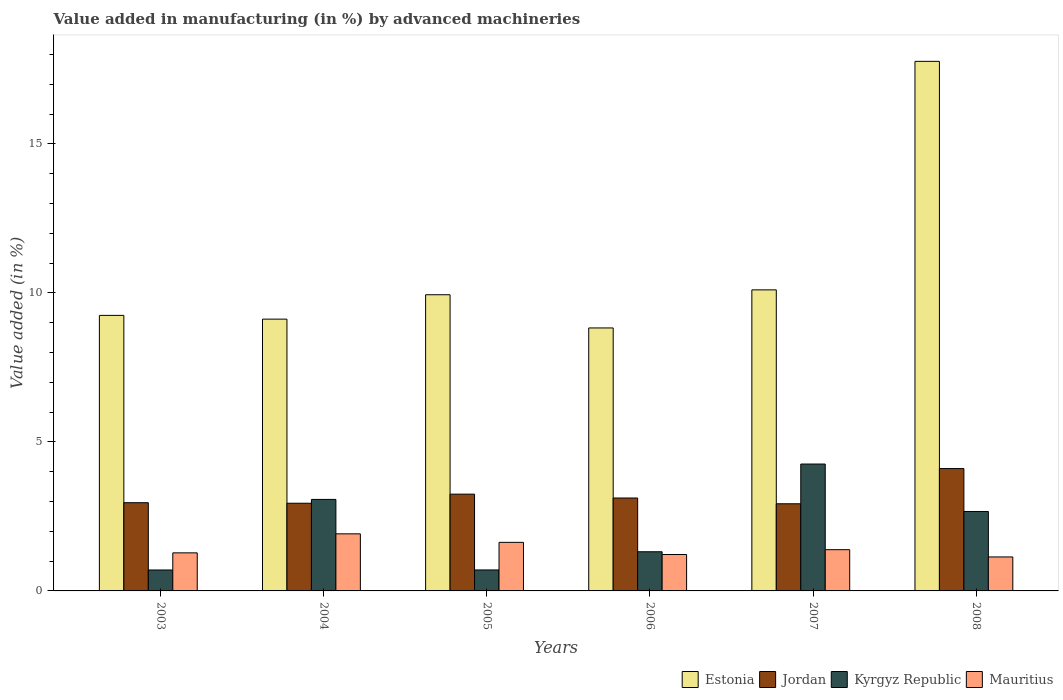How many bars are there on the 3rd tick from the left?
Keep it short and to the point. 4. What is the label of the 5th group of bars from the left?
Offer a terse response. 2007. In how many cases, is the number of bars for a given year not equal to the number of legend labels?
Make the answer very short. 0. What is the percentage of value added in manufacturing by advanced machineries in Mauritius in 2004?
Provide a short and direct response. 1.92. Across all years, what is the maximum percentage of value added in manufacturing by advanced machineries in Kyrgyz Republic?
Provide a short and direct response. 4.26. Across all years, what is the minimum percentage of value added in manufacturing by advanced machineries in Mauritius?
Provide a short and direct response. 1.14. In which year was the percentage of value added in manufacturing by advanced machineries in Kyrgyz Republic maximum?
Make the answer very short. 2007. In which year was the percentage of value added in manufacturing by advanced machineries in Mauritius minimum?
Provide a short and direct response. 2008. What is the total percentage of value added in manufacturing by advanced machineries in Jordan in the graph?
Ensure brevity in your answer.  19.3. What is the difference between the percentage of value added in manufacturing by advanced machineries in Kyrgyz Republic in 2003 and that in 2005?
Your answer should be compact. -0. What is the difference between the percentage of value added in manufacturing by advanced machineries in Mauritius in 2008 and the percentage of value added in manufacturing by advanced machineries in Jordan in 2004?
Provide a short and direct response. -1.8. What is the average percentage of value added in manufacturing by advanced machineries in Mauritius per year?
Offer a terse response. 1.43. In the year 2003, what is the difference between the percentage of value added in manufacturing by advanced machineries in Mauritius and percentage of value added in manufacturing by advanced machineries in Jordan?
Offer a terse response. -1.68. In how many years, is the percentage of value added in manufacturing by advanced machineries in Jordan greater than 7 %?
Offer a very short reply. 0. What is the ratio of the percentage of value added in manufacturing by advanced machineries in Mauritius in 2006 to that in 2008?
Your answer should be very brief. 1.07. Is the difference between the percentage of value added in manufacturing by advanced machineries in Mauritius in 2006 and 2007 greater than the difference between the percentage of value added in manufacturing by advanced machineries in Jordan in 2006 and 2007?
Ensure brevity in your answer.  No. What is the difference between the highest and the second highest percentage of value added in manufacturing by advanced machineries in Mauritius?
Ensure brevity in your answer.  0.29. What is the difference between the highest and the lowest percentage of value added in manufacturing by advanced machineries in Jordan?
Ensure brevity in your answer.  1.18. Is the sum of the percentage of value added in manufacturing by advanced machineries in Kyrgyz Republic in 2006 and 2007 greater than the maximum percentage of value added in manufacturing by advanced machineries in Estonia across all years?
Your answer should be compact. No. What does the 1st bar from the left in 2003 represents?
Ensure brevity in your answer.  Estonia. What does the 4th bar from the right in 2007 represents?
Your answer should be compact. Estonia. Are all the bars in the graph horizontal?
Offer a terse response. No. Does the graph contain any zero values?
Your answer should be compact. No. Does the graph contain grids?
Offer a terse response. No. What is the title of the graph?
Give a very brief answer. Value added in manufacturing (in %) by advanced machineries. What is the label or title of the X-axis?
Provide a succinct answer. Years. What is the label or title of the Y-axis?
Your answer should be very brief. Value added (in %). What is the Value added (in %) of Estonia in 2003?
Ensure brevity in your answer.  9.25. What is the Value added (in %) in Jordan in 2003?
Your answer should be very brief. 2.96. What is the Value added (in %) of Kyrgyz Republic in 2003?
Provide a short and direct response. 0.7. What is the Value added (in %) in Mauritius in 2003?
Offer a very short reply. 1.28. What is the Value added (in %) of Estonia in 2004?
Offer a terse response. 9.12. What is the Value added (in %) in Jordan in 2004?
Ensure brevity in your answer.  2.94. What is the Value added (in %) of Kyrgyz Republic in 2004?
Your response must be concise. 3.07. What is the Value added (in %) in Mauritius in 2004?
Provide a succinct answer. 1.92. What is the Value added (in %) in Estonia in 2005?
Ensure brevity in your answer.  9.94. What is the Value added (in %) of Jordan in 2005?
Your response must be concise. 3.25. What is the Value added (in %) of Kyrgyz Republic in 2005?
Ensure brevity in your answer.  0.7. What is the Value added (in %) of Mauritius in 2005?
Provide a succinct answer. 1.63. What is the Value added (in %) in Estonia in 2006?
Your response must be concise. 8.83. What is the Value added (in %) of Jordan in 2006?
Make the answer very short. 3.12. What is the Value added (in %) in Kyrgyz Republic in 2006?
Keep it short and to the point. 1.31. What is the Value added (in %) in Mauritius in 2006?
Offer a very short reply. 1.22. What is the Value added (in %) in Estonia in 2007?
Your response must be concise. 10.1. What is the Value added (in %) in Jordan in 2007?
Provide a succinct answer. 2.92. What is the Value added (in %) in Kyrgyz Republic in 2007?
Provide a succinct answer. 4.26. What is the Value added (in %) of Mauritius in 2007?
Keep it short and to the point. 1.38. What is the Value added (in %) of Estonia in 2008?
Your answer should be very brief. 17.77. What is the Value added (in %) of Jordan in 2008?
Your answer should be compact. 4.11. What is the Value added (in %) of Kyrgyz Republic in 2008?
Give a very brief answer. 2.67. What is the Value added (in %) of Mauritius in 2008?
Ensure brevity in your answer.  1.14. Across all years, what is the maximum Value added (in %) of Estonia?
Your answer should be compact. 17.77. Across all years, what is the maximum Value added (in %) of Jordan?
Give a very brief answer. 4.11. Across all years, what is the maximum Value added (in %) in Kyrgyz Republic?
Provide a short and direct response. 4.26. Across all years, what is the maximum Value added (in %) in Mauritius?
Your answer should be compact. 1.92. Across all years, what is the minimum Value added (in %) in Estonia?
Provide a succinct answer. 8.83. Across all years, what is the minimum Value added (in %) in Jordan?
Your answer should be very brief. 2.92. Across all years, what is the minimum Value added (in %) of Kyrgyz Republic?
Ensure brevity in your answer.  0.7. Across all years, what is the minimum Value added (in %) of Mauritius?
Provide a succinct answer. 1.14. What is the total Value added (in %) of Estonia in the graph?
Keep it short and to the point. 65.01. What is the total Value added (in %) of Jordan in the graph?
Offer a very short reply. 19.3. What is the total Value added (in %) of Kyrgyz Republic in the graph?
Give a very brief answer. 12.72. What is the total Value added (in %) in Mauritius in the graph?
Make the answer very short. 8.57. What is the difference between the Value added (in %) of Estonia in 2003 and that in 2004?
Keep it short and to the point. 0.13. What is the difference between the Value added (in %) of Jordan in 2003 and that in 2004?
Your response must be concise. 0.02. What is the difference between the Value added (in %) in Kyrgyz Republic in 2003 and that in 2004?
Your answer should be very brief. -2.37. What is the difference between the Value added (in %) in Mauritius in 2003 and that in 2004?
Provide a short and direct response. -0.64. What is the difference between the Value added (in %) in Estonia in 2003 and that in 2005?
Keep it short and to the point. -0.69. What is the difference between the Value added (in %) in Jordan in 2003 and that in 2005?
Offer a terse response. -0.29. What is the difference between the Value added (in %) of Kyrgyz Republic in 2003 and that in 2005?
Provide a succinct answer. -0. What is the difference between the Value added (in %) of Mauritius in 2003 and that in 2005?
Ensure brevity in your answer.  -0.35. What is the difference between the Value added (in %) of Estonia in 2003 and that in 2006?
Your answer should be compact. 0.42. What is the difference between the Value added (in %) in Jordan in 2003 and that in 2006?
Ensure brevity in your answer.  -0.16. What is the difference between the Value added (in %) of Kyrgyz Republic in 2003 and that in 2006?
Make the answer very short. -0.61. What is the difference between the Value added (in %) of Mauritius in 2003 and that in 2006?
Ensure brevity in your answer.  0.06. What is the difference between the Value added (in %) of Estonia in 2003 and that in 2007?
Your answer should be very brief. -0.86. What is the difference between the Value added (in %) of Jordan in 2003 and that in 2007?
Make the answer very short. 0.04. What is the difference between the Value added (in %) in Kyrgyz Republic in 2003 and that in 2007?
Your answer should be compact. -3.56. What is the difference between the Value added (in %) of Mauritius in 2003 and that in 2007?
Offer a very short reply. -0.11. What is the difference between the Value added (in %) in Estonia in 2003 and that in 2008?
Your response must be concise. -8.53. What is the difference between the Value added (in %) of Jordan in 2003 and that in 2008?
Offer a terse response. -1.15. What is the difference between the Value added (in %) in Kyrgyz Republic in 2003 and that in 2008?
Offer a terse response. -1.96. What is the difference between the Value added (in %) of Mauritius in 2003 and that in 2008?
Offer a terse response. 0.14. What is the difference between the Value added (in %) of Estonia in 2004 and that in 2005?
Your response must be concise. -0.82. What is the difference between the Value added (in %) of Jordan in 2004 and that in 2005?
Keep it short and to the point. -0.31. What is the difference between the Value added (in %) in Kyrgyz Republic in 2004 and that in 2005?
Offer a very short reply. 2.37. What is the difference between the Value added (in %) in Mauritius in 2004 and that in 2005?
Keep it short and to the point. 0.29. What is the difference between the Value added (in %) in Estonia in 2004 and that in 2006?
Provide a short and direct response. 0.3. What is the difference between the Value added (in %) of Jordan in 2004 and that in 2006?
Make the answer very short. -0.18. What is the difference between the Value added (in %) in Kyrgyz Republic in 2004 and that in 2006?
Provide a short and direct response. 1.76. What is the difference between the Value added (in %) of Mauritius in 2004 and that in 2006?
Your answer should be compact. 0.69. What is the difference between the Value added (in %) of Estonia in 2004 and that in 2007?
Provide a succinct answer. -0.98. What is the difference between the Value added (in %) of Jordan in 2004 and that in 2007?
Provide a succinct answer. 0.02. What is the difference between the Value added (in %) in Kyrgyz Republic in 2004 and that in 2007?
Make the answer very short. -1.19. What is the difference between the Value added (in %) of Mauritius in 2004 and that in 2007?
Ensure brevity in your answer.  0.53. What is the difference between the Value added (in %) in Estonia in 2004 and that in 2008?
Offer a terse response. -8.65. What is the difference between the Value added (in %) of Jordan in 2004 and that in 2008?
Give a very brief answer. -1.16. What is the difference between the Value added (in %) in Kyrgyz Republic in 2004 and that in 2008?
Make the answer very short. 0.4. What is the difference between the Value added (in %) of Mauritius in 2004 and that in 2008?
Your response must be concise. 0.78. What is the difference between the Value added (in %) of Estonia in 2005 and that in 2006?
Provide a short and direct response. 1.11. What is the difference between the Value added (in %) in Jordan in 2005 and that in 2006?
Provide a succinct answer. 0.13. What is the difference between the Value added (in %) in Kyrgyz Republic in 2005 and that in 2006?
Give a very brief answer. -0.61. What is the difference between the Value added (in %) in Mauritius in 2005 and that in 2006?
Ensure brevity in your answer.  0.41. What is the difference between the Value added (in %) of Estonia in 2005 and that in 2007?
Your answer should be compact. -0.16. What is the difference between the Value added (in %) of Jordan in 2005 and that in 2007?
Provide a short and direct response. 0.32. What is the difference between the Value added (in %) in Kyrgyz Republic in 2005 and that in 2007?
Keep it short and to the point. -3.55. What is the difference between the Value added (in %) of Mauritius in 2005 and that in 2007?
Your answer should be very brief. 0.25. What is the difference between the Value added (in %) of Estonia in 2005 and that in 2008?
Your response must be concise. -7.83. What is the difference between the Value added (in %) in Jordan in 2005 and that in 2008?
Provide a short and direct response. -0.86. What is the difference between the Value added (in %) in Kyrgyz Republic in 2005 and that in 2008?
Give a very brief answer. -1.96. What is the difference between the Value added (in %) in Mauritius in 2005 and that in 2008?
Provide a succinct answer. 0.49. What is the difference between the Value added (in %) of Estonia in 2006 and that in 2007?
Make the answer very short. -1.28. What is the difference between the Value added (in %) in Jordan in 2006 and that in 2007?
Your response must be concise. 0.19. What is the difference between the Value added (in %) in Kyrgyz Republic in 2006 and that in 2007?
Offer a terse response. -2.94. What is the difference between the Value added (in %) in Mauritius in 2006 and that in 2007?
Keep it short and to the point. -0.16. What is the difference between the Value added (in %) of Estonia in 2006 and that in 2008?
Provide a succinct answer. -8.95. What is the difference between the Value added (in %) of Jordan in 2006 and that in 2008?
Your response must be concise. -0.99. What is the difference between the Value added (in %) in Kyrgyz Republic in 2006 and that in 2008?
Provide a short and direct response. -1.35. What is the difference between the Value added (in %) in Mauritius in 2006 and that in 2008?
Provide a succinct answer. 0.08. What is the difference between the Value added (in %) in Estonia in 2007 and that in 2008?
Ensure brevity in your answer.  -7.67. What is the difference between the Value added (in %) of Jordan in 2007 and that in 2008?
Ensure brevity in your answer.  -1.18. What is the difference between the Value added (in %) in Kyrgyz Republic in 2007 and that in 2008?
Make the answer very short. 1.59. What is the difference between the Value added (in %) of Mauritius in 2007 and that in 2008?
Ensure brevity in your answer.  0.24. What is the difference between the Value added (in %) in Estonia in 2003 and the Value added (in %) in Jordan in 2004?
Provide a short and direct response. 6.3. What is the difference between the Value added (in %) in Estonia in 2003 and the Value added (in %) in Kyrgyz Republic in 2004?
Your answer should be compact. 6.18. What is the difference between the Value added (in %) in Estonia in 2003 and the Value added (in %) in Mauritius in 2004?
Ensure brevity in your answer.  7.33. What is the difference between the Value added (in %) in Jordan in 2003 and the Value added (in %) in Kyrgyz Republic in 2004?
Keep it short and to the point. -0.11. What is the difference between the Value added (in %) in Jordan in 2003 and the Value added (in %) in Mauritius in 2004?
Provide a short and direct response. 1.04. What is the difference between the Value added (in %) of Kyrgyz Republic in 2003 and the Value added (in %) of Mauritius in 2004?
Keep it short and to the point. -1.21. What is the difference between the Value added (in %) in Estonia in 2003 and the Value added (in %) in Jordan in 2005?
Give a very brief answer. 6. What is the difference between the Value added (in %) in Estonia in 2003 and the Value added (in %) in Kyrgyz Republic in 2005?
Your answer should be compact. 8.54. What is the difference between the Value added (in %) of Estonia in 2003 and the Value added (in %) of Mauritius in 2005?
Offer a terse response. 7.62. What is the difference between the Value added (in %) of Jordan in 2003 and the Value added (in %) of Kyrgyz Republic in 2005?
Your answer should be very brief. 2.26. What is the difference between the Value added (in %) of Jordan in 2003 and the Value added (in %) of Mauritius in 2005?
Ensure brevity in your answer.  1.33. What is the difference between the Value added (in %) of Kyrgyz Republic in 2003 and the Value added (in %) of Mauritius in 2005?
Offer a terse response. -0.93. What is the difference between the Value added (in %) of Estonia in 2003 and the Value added (in %) of Jordan in 2006?
Keep it short and to the point. 6.13. What is the difference between the Value added (in %) in Estonia in 2003 and the Value added (in %) in Kyrgyz Republic in 2006?
Offer a very short reply. 7.93. What is the difference between the Value added (in %) in Estonia in 2003 and the Value added (in %) in Mauritius in 2006?
Your response must be concise. 8.02. What is the difference between the Value added (in %) in Jordan in 2003 and the Value added (in %) in Kyrgyz Republic in 2006?
Your answer should be compact. 1.65. What is the difference between the Value added (in %) of Jordan in 2003 and the Value added (in %) of Mauritius in 2006?
Keep it short and to the point. 1.74. What is the difference between the Value added (in %) in Kyrgyz Republic in 2003 and the Value added (in %) in Mauritius in 2006?
Offer a terse response. -0.52. What is the difference between the Value added (in %) of Estonia in 2003 and the Value added (in %) of Jordan in 2007?
Your answer should be very brief. 6.32. What is the difference between the Value added (in %) in Estonia in 2003 and the Value added (in %) in Kyrgyz Republic in 2007?
Keep it short and to the point. 4.99. What is the difference between the Value added (in %) of Estonia in 2003 and the Value added (in %) of Mauritius in 2007?
Give a very brief answer. 7.86. What is the difference between the Value added (in %) in Jordan in 2003 and the Value added (in %) in Kyrgyz Republic in 2007?
Your response must be concise. -1.3. What is the difference between the Value added (in %) of Jordan in 2003 and the Value added (in %) of Mauritius in 2007?
Provide a short and direct response. 1.58. What is the difference between the Value added (in %) in Kyrgyz Republic in 2003 and the Value added (in %) in Mauritius in 2007?
Keep it short and to the point. -0.68. What is the difference between the Value added (in %) of Estonia in 2003 and the Value added (in %) of Jordan in 2008?
Provide a short and direct response. 5.14. What is the difference between the Value added (in %) of Estonia in 2003 and the Value added (in %) of Kyrgyz Republic in 2008?
Your answer should be very brief. 6.58. What is the difference between the Value added (in %) of Estonia in 2003 and the Value added (in %) of Mauritius in 2008?
Offer a very short reply. 8.11. What is the difference between the Value added (in %) in Jordan in 2003 and the Value added (in %) in Kyrgyz Republic in 2008?
Your answer should be compact. 0.29. What is the difference between the Value added (in %) in Jordan in 2003 and the Value added (in %) in Mauritius in 2008?
Provide a succinct answer. 1.82. What is the difference between the Value added (in %) in Kyrgyz Republic in 2003 and the Value added (in %) in Mauritius in 2008?
Your answer should be compact. -0.44. What is the difference between the Value added (in %) of Estonia in 2004 and the Value added (in %) of Jordan in 2005?
Provide a short and direct response. 5.87. What is the difference between the Value added (in %) of Estonia in 2004 and the Value added (in %) of Kyrgyz Republic in 2005?
Provide a short and direct response. 8.42. What is the difference between the Value added (in %) in Estonia in 2004 and the Value added (in %) in Mauritius in 2005?
Provide a succinct answer. 7.49. What is the difference between the Value added (in %) in Jordan in 2004 and the Value added (in %) in Kyrgyz Republic in 2005?
Your answer should be compact. 2.24. What is the difference between the Value added (in %) of Jordan in 2004 and the Value added (in %) of Mauritius in 2005?
Make the answer very short. 1.31. What is the difference between the Value added (in %) in Kyrgyz Republic in 2004 and the Value added (in %) in Mauritius in 2005?
Provide a short and direct response. 1.44. What is the difference between the Value added (in %) in Estonia in 2004 and the Value added (in %) in Jordan in 2006?
Offer a very short reply. 6. What is the difference between the Value added (in %) in Estonia in 2004 and the Value added (in %) in Kyrgyz Republic in 2006?
Keep it short and to the point. 7.81. What is the difference between the Value added (in %) of Estonia in 2004 and the Value added (in %) of Mauritius in 2006?
Your answer should be compact. 7.9. What is the difference between the Value added (in %) of Jordan in 2004 and the Value added (in %) of Kyrgyz Republic in 2006?
Offer a terse response. 1.63. What is the difference between the Value added (in %) of Jordan in 2004 and the Value added (in %) of Mauritius in 2006?
Offer a terse response. 1.72. What is the difference between the Value added (in %) of Kyrgyz Republic in 2004 and the Value added (in %) of Mauritius in 2006?
Your response must be concise. 1.85. What is the difference between the Value added (in %) in Estonia in 2004 and the Value added (in %) in Jordan in 2007?
Offer a terse response. 6.2. What is the difference between the Value added (in %) of Estonia in 2004 and the Value added (in %) of Kyrgyz Republic in 2007?
Provide a succinct answer. 4.86. What is the difference between the Value added (in %) in Estonia in 2004 and the Value added (in %) in Mauritius in 2007?
Provide a succinct answer. 7.74. What is the difference between the Value added (in %) of Jordan in 2004 and the Value added (in %) of Kyrgyz Republic in 2007?
Your response must be concise. -1.32. What is the difference between the Value added (in %) in Jordan in 2004 and the Value added (in %) in Mauritius in 2007?
Your response must be concise. 1.56. What is the difference between the Value added (in %) of Kyrgyz Republic in 2004 and the Value added (in %) of Mauritius in 2007?
Offer a terse response. 1.69. What is the difference between the Value added (in %) in Estonia in 2004 and the Value added (in %) in Jordan in 2008?
Offer a terse response. 5.02. What is the difference between the Value added (in %) of Estonia in 2004 and the Value added (in %) of Kyrgyz Republic in 2008?
Your response must be concise. 6.45. What is the difference between the Value added (in %) of Estonia in 2004 and the Value added (in %) of Mauritius in 2008?
Your answer should be very brief. 7.98. What is the difference between the Value added (in %) in Jordan in 2004 and the Value added (in %) in Kyrgyz Republic in 2008?
Your answer should be very brief. 0.28. What is the difference between the Value added (in %) of Jordan in 2004 and the Value added (in %) of Mauritius in 2008?
Provide a succinct answer. 1.8. What is the difference between the Value added (in %) in Kyrgyz Republic in 2004 and the Value added (in %) in Mauritius in 2008?
Give a very brief answer. 1.93. What is the difference between the Value added (in %) of Estonia in 2005 and the Value added (in %) of Jordan in 2006?
Provide a short and direct response. 6.82. What is the difference between the Value added (in %) in Estonia in 2005 and the Value added (in %) in Kyrgyz Republic in 2006?
Make the answer very short. 8.63. What is the difference between the Value added (in %) in Estonia in 2005 and the Value added (in %) in Mauritius in 2006?
Keep it short and to the point. 8.72. What is the difference between the Value added (in %) of Jordan in 2005 and the Value added (in %) of Kyrgyz Republic in 2006?
Offer a terse response. 1.93. What is the difference between the Value added (in %) in Jordan in 2005 and the Value added (in %) in Mauritius in 2006?
Give a very brief answer. 2.03. What is the difference between the Value added (in %) in Kyrgyz Republic in 2005 and the Value added (in %) in Mauritius in 2006?
Give a very brief answer. -0.52. What is the difference between the Value added (in %) of Estonia in 2005 and the Value added (in %) of Jordan in 2007?
Your answer should be compact. 7.01. What is the difference between the Value added (in %) of Estonia in 2005 and the Value added (in %) of Kyrgyz Republic in 2007?
Provide a short and direct response. 5.68. What is the difference between the Value added (in %) in Estonia in 2005 and the Value added (in %) in Mauritius in 2007?
Your answer should be very brief. 8.56. What is the difference between the Value added (in %) in Jordan in 2005 and the Value added (in %) in Kyrgyz Republic in 2007?
Offer a very short reply. -1.01. What is the difference between the Value added (in %) of Jordan in 2005 and the Value added (in %) of Mauritius in 2007?
Provide a short and direct response. 1.86. What is the difference between the Value added (in %) of Kyrgyz Republic in 2005 and the Value added (in %) of Mauritius in 2007?
Offer a very short reply. -0.68. What is the difference between the Value added (in %) in Estonia in 2005 and the Value added (in %) in Jordan in 2008?
Your answer should be compact. 5.83. What is the difference between the Value added (in %) in Estonia in 2005 and the Value added (in %) in Kyrgyz Republic in 2008?
Your answer should be compact. 7.27. What is the difference between the Value added (in %) of Estonia in 2005 and the Value added (in %) of Mauritius in 2008?
Keep it short and to the point. 8.8. What is the difference between the Value added (in %) of Jordan in 2005 and the Value added (in %) of Kyrgyz Republic in 2008?
Provide a succinct answer. 0.58. What is the difference between the Value added (in %) of Jordan in 2005 and the Value added (in %) of Mauritius in 2008?
Your answer should be very brief. 2.11. What is the difference between the Value added (in %) of Kyrgyz Republic in 2005 and the Value added (in %) of Mauritius in 2008?
Offer a very short reply. -0.44. What is the difference between the Value added (in %) of Estonia in 2006 and the Value added (in %) of Jordan in 2007?
Offer a very short reply. 5.9. What is the difference between the Value added (in %) in Estonia in 2006 and the Value added (in %) in Kyrgyz Republic in 2007?
Offer a very short reply. 4.57. What is the difference between the Value added (in %) in Estonia in 2006 and the Value added (in %) in Mauritius in 2007?
Your answer should be very brief. 7.44. What is the difference between the Value added (in %) in Jordan in 2006 and the Value added (in %) in Kyrgyz Republic in 2007?
Keep it short and to the point. -1.14. What is the difference between the Value added (in %) in Jordan in 2006 and the Value added (in %) in Mauritius in 2007?
Offer a terse response. 1.73. What is the difference between the Value added (in %) in Kyrgyz Republic in 2006 and the Value added (in %) in Mauritius in 2007?
Keep it short and to the point. -0.07. What is the difference between the Value added (in %) of Estonia in 2006 and the Value added (in %) of Jordan in 2008?
Your response must be concise. 4.72. What is the difference between the Value added (in %) of Estonia in 2006 and the Value added (in %) of Kyrgyz Republic in 2008?
Your response must be concise. 6.16. What is the difference between the Value added (in %) in Estonia in 2006 and the Value added (in %) in Mauritius in 2008?
Provide a short and direct response. 7.69. What is the difference between the Value added (in %) of Jordan in 2006 and the Value added (in %) of Kyrgyz Republic in 2008?
Make the answer very short. 0.45. What is the difference between the Value added (in %) of Jordan in 2006 and the Value added (in %) of Mauritius in 2008?
Your answer should be compact. 1.98. What is the difference between the Value added (in %) of Kyrgyz Republic in 2006 and the Value added (in %) of Mauritius in 2008?
Your answer should be very brief. 0.17. What is the difference between the Value added (in %) in Estonia in 2007 and the Value added (in %) in Jordan in 2008?
Offer a very short reply. 6. What is the difference between the Value added (in %) of Estonia in 2007 and the Value added (in %) of Kyrgyz Republic in 2008?
Provide a succinct answer. 7.44. What is the difference between the Value added (in %) of Estonia in 2007 and the Value added (in %) of Mauritius in 2008?
Keep it short and to the point. 8.96. What is the difference between the Value added (in %) in Jordan in 2007 and the Value added (in %) in Kyrgyz Republic in 2008?
Your answer should be very brief. 0.26. What is the difference between the Value added (in %) of Jordan in 2007 and the Value added (in %) of Mauritius in 2008?
Your response must be concise. 1.78. What is the difference between the Value added (in %) of Kyrgyz Republic in 2007 and the Value added (in %) of Mauritius in 2008?
Offer a terse response. 3.12. What is the average Value added (in %) of Estonia per year?
Your answer should be very brief. 10.83. What is the average Value added (in %) in Jordan per year?
Give a very brief answer. 3.22. What is the average Value added (in %) of Kyrgyz Republic per year?
Keep it short and to the point. 2.12. What is the average Value added (in %) of Mauritius per year?
Your answer should be compact. 1.43. In the year 2003, what is the difference between the Value added (in %) in Estonia and Value added (in %) in Jordan?
Your response must be concise. 6.29. In the year 2003, what is the difference between the Value added (in %) of Estonia and Value added (in %) of Kyrgyz Republic?
Keep it short and to the point. 8.54. In the year 2003, what is the difference between the Value added (in %) of Estonia and Value added (in %) of Mauritius?
Your answer should be compact. 7.97. In the year 2003, what is the difference between the Value added (in %) of Jordan and Value added (in %) of Kyrgyz Republic?
Offer a terse response. 2.26. In the year 2003, what is the difference between the Value added (in %) in Jordan and Value added (in %) in Mauritius?
Keep it short and to the point. 1.68. In the year 2003, what is the difference between the Value added (in %) in Kyrgyz Republic and Value added (in %) in Mauritius?
Offer a very short reply. -0.57. In the year 2004, what is the difference between the Value added (in %) of Estonia and Value added (in %) of Jordan?
Your answer should be very brief. 6.18. In the year 2004, what is the difference between the Value added (in %) in Estonia and Value added (in %) in Kyrgyz Republic?
Offer a terse response. 6.05. In the year 2004, what is the difference between the Value added (in %) in Estonia and Value added (in %) in Mauritius?
Your answer should be compact. 7.21. In the year 2004, what is the difference between the Value added (in %) in Jordan and Value added (in %) in Kyrgyz Republic?
Make the answer very short. -0.13. In the year 2004, what is the difference between the Value added (in %) in Jordan and Value added (in %) in Mauritius?
Your answer should be very brief. 1.03. In the year 2004, what is the difference between the Value added (in %) of Kyrgyz Republic and Value added (in %) of Mauritius?
Give a very brief answer. 1.15. In the year 2005, what is the difference between the Value added (in %) in Estonia and Value added (in %) in Jordan?
Your answer should be compact. 6.69. In the year 2005, what is the difference between the Value added (in %) in Estonia and Value added (in %) in Kyrgyz Republic?
Make the answer very short. 9.24. In the year 2005, what is the difference between the Value added (in %) in Estonia and Value added (in %) in Mauritius?
Keep it short and to the point. 8.31. In the year 2005, what is the difference between the Value added (in %) in Jordan and Value added (in %) in Kyrgyz Republic?
Ensure brevity in your answer.  2.54. In the year 2005, what is the difference between the Value added (in %) in Jordan and Value added (in %) in Mauritius?
Ensure brevity in your answer.  1.62. In the year 2005, what is the difference between the Value added (in %) of Kyrgyz Republic and Value added (in %) of Mauritius?
Offer a very short reply. -0.93. In the year 2006, what is the difference between the Value added (in %) of Estonia and Value added (in %) of Jordan?
Offer a very short reply. 5.71. In the year 2006, what is the difference between the Value added (in %) in Estonia and Value added (in %) in Kyrgyz Republic?
Provide a succinct answer. 7.51. In the year 2006, what is the difference between the Value added (in %) of Estonia and Value added (in %) of Mauritius?
Give a very brief answer. 7.6. In the year 2006, what is the difference between the Value added (in %) of Jordan and Value added (in %) of Kyrgyz Republic?
Provide a short and direct response. 1.8. In the year 2006, what is the difference between the Value added (in %) in Jordan and Value added (in %) in Mauritius?
Your response must be concise. 1.9. In the year 2006, what is the difference between the Value added (in %) in Kyrgyz Republic and Value added (in %) in Mauritius?
Offer a very short reply. 0.09. In the year 2007, what is the difference between the Value added (in %) of Estonia and Value added (in %) of Jordan?
Offer a very short reply. 7.18. In the year 2007, what is the difference between the Value added (in %) in Estonia and Value added (in %) in Kyrgyz Republic?
Make the answer very short. 5.85. In the year 2007, what is the difference between the Value added (in %) of Estonia and Value added (in %) of Mauritius?
Keep it short and to the point. 8.72. In the year 2007, what is the difference between the Value added (in %) in Jordan and Value added (in %) in Kyrgyz Republic?
Make the answer very short. -1.33. In the year 2007, what is the difference between the Value added (in %) of Jordan and Value added (in %) of Mauritius?
Provide a succinct answer. 1.54. In the year 2007, what is the difference between the Value added (in %) in Kyrgyz Republic and Value added (in %) in Mauritius?
Keep it short and to the point. 2.87. In the year 2008, what is the difference between the Value added (in %) in Estonia and Value added (in %) in Jordan?
Offer a very short reply. 13.67. In the year 2008, what is the difference between the Value added (in %) in Estonia and Value added (in %) in Kyrgyz Republic?
Your response must be concise. 15.11. In the year 2008, what is the difference between the Value added (in %) of Estonia and Value added (in %) of Mauritius?
Your answer should be very brief. 16.63. In the year 2008, what is the difference between the Value added (in %) in Jordan and Value added (in %) in Kyrgyz Republic?
Offer a terse response. 1.44. In the year 2008, what is the difference between the Value added (in %) of Jordan and Value added (in %) of Mauritius?
Provide a short and direct response. 2.97. In the year 2008, what is the difference between the Value added (in %) of Kyrgyz Republic and Value added (in %) of Mauritius?
Make the answer very short. 1.53. What is the ratio of the Value added (in %) of Estonia in 2003 to that in 2004?
Give a very brief answer. 1.01. What is the ratio of the Value added (in %) in Jordan in 2003 to that in 2004?
Give a very brief answer. 1.01. What is the ratio of the Value added (in %) in Kyrgyz Republic in 2003 to that in 2004?
Provide a short and direct response. 0.23. What is the ratio of the Value added (in %) in Estonia in 2003 to that in 2005?
Your answer should be very brief. 0.93. What is the ratio of the Value added (in %) of Jordan in 2003 to that in 2005?
Make the answer very short. 0.91. What is the ratio of the Value added (in %) in Mauritius in 2003 to that in 2005?
Keep it short and to the point. 0.78. What is the ratio of the Value added (in %) of Estonia in 2003 to that in 2006?
Keep it short and to the point. 1.05. What is the ratio of the Value added (in %) in Jordan in 2003 to that in 2006?
Provide a succinct answer. 0.95. What is the ratio of the Value added (in %) in Kyrgyz Republic in 2003 to that in 2006?
Your answer should be compact. 0.53. What is the ratio of the Value added (in %) of Mauritius in 2003 to that in 2006?
Give a very brief answer. 1.05. What is the ratio of the Value added (in %) of Estonia in 2003 to that in 2007?
Offer a terse response. 0.92. What is the ratio of the Value added (in %) in Jordan in 2003 to that in 2007?
Your answer should be very brief. 1.01. What is the ratio of the Value added (in %) in Kyrgyz Republic in 2003 to that in 2007?
Keep it short and to the point. 0.17. What is the ratio of the Value added (in %) of Mauritius in 2003 to that in 2007?
Make the answer very short. 0.92. What is the ratio of the Value added (in %) of Estonia in 2003 to that in 2008?
Your response must be concise. 0.52. What is the ratio of the Value added (in %) of Jordan in 2003 to that in 2008?
Your response must be concise. 0.72. What is the ratio of the Value added (in %) of Kyrgyz Republic in 2003 to that in 2008?
Make the answer very short. 0.26. What is the ratio of the Value added (in %) in Mauritius in 2003 to that in 2008?
Provide a short and direct response. 1.12. What is the ratio of the Value added (in %) in Estonia in 2004 to that in 2005?
Offer a terse response. 0.92. What is the ratio of the Value added (in %) of Jordan in 2004 to that in 2005?
Make the answer very short. 0.91. What is the ratio of the Value added (in %) in Kyrgyz Republic in 2004 to that in 2005?
Your response must be concise. 4.36. What is the ratio of the Value added (in %) of Mauritius in 2004 to that in 2005?
Ensure brevity in your answer.  1.18. What is the ratio of the Value added (in %) in Estonia in 2004 to that in 2006?
Make the answer very short. 1.03. What is the ratio of the Value added (in %) of Jordan in 2004 to that in 2006?
Your answer should be very brief. 0.94. What is the ratio of the Value added (in %) of Kyrgyz Republic in 2004 to that in 2006?
Offer a very short reply. 2.34. What is the ratio of the Value added (in %) of Mauritius in 2004 to that in 2006?
Your response must be concise. 1.57. What is the ratio of the Value added (in %) in Estonia in 2004 to that in 2007?
Provide a short and direct response. 0.9. What is the ratio of the Value added (in %) in Kyrgyz Republic in 2004 to that in 2007?
Your response must be concise. 0.72. What is the ratio of the Value added (in %) of Mauritius in 2004 to that in 2007?
Keep it short and to the point. 1.38. What is the ratio of the Value added (in %) in Estonia in 2004 to that in 2008?
Keep it short and to the point. 0.51. What is the ratio of the Value added (in %) of Jordan in 2004 to that in 2008?
Provide a short and direct response. 0.72. What is the ratio of the Value added (in %) of Kyrgyz Republic in 2004 to that in 2008?
Provide a succinct answer. 1.15. What is the ratio of the Value added (in %) in Mauritius in 2004 to that in 2008?
Your answer should be very brief. 1.68. What is the ratio of the Value added (in %) in Estonia in 2005 to that in 2006?
Offer a very short reply. 1.13. What is the ratio of the Value added (in %) in Jordan in 2005 to that in 2006?
Offer a very short reply. 1.04. What is the ratio of the Value added (in %) in Kyrgyz Republic in 2005 to that in 2006?
Offer a very short reply. 0.54. What is the ratio of the Value added (in %) of Mauritius in 2005 to that in 2006?
Offer a terse response. 1.33. What is the ratio of the Value added (in %) of Estonia in 2005 to that in 2007?
Provide a succinct answer. 0.98. What is the ratio of the Value added (in %) of Jordan in 2005 to that in 2007?
Ensure brevity in your answer.  1.11. What is the ratio of the Value added (in %) of Kyrgyz Republic in 2005 to that in 2007?
Give a very brief answer. 0.17. What is the ratio of the Value added (in %) of Mauritius in 2005 to that in 2007?
Your answer should be very brief. 1.18. What is the ratio of the Value added (in %) of Estonia in 2005 to that in 2008?
Make the answer very short. 0.56. What is the ratio of the Value added (in %) of Jordan in 2005 to that in 2008?
Make the answer very short. 0.79. What is the ratio of the Value added (in %) in Kyrgyz Republic in 2005 to that in 2008?
Your response must be concise. 0.26. What is the ratio of the Value added (in %) in Mauritius in 2005 to that in 2008?
Ensure brevity in your answer.  1.43. What is the ratio of the Value added (in %) in Estonia in 2006 to that in 2007?
Make the answer very short. 0.87. What is the ratio of the Value added (in %) in Jordan in 2006 to that in 2007?
Your answer should be very brief. 1.07. What is the ratio of the Value added (in %) in Kyrgyz Republic in 2006 to that in 2007?
Your response must be concise. 0.31. What is the ratio of the Value added (in %) of Mauritius in 2006 to that in 2007?
Ensure brevity in your answer.  0.88. What is the ratio of the Value added (in %) in Estonia in 2006 to that in 2008?
Your answer should be very brief. 0.5. What is the ratio of the Value added (in %) of Jordan in 2006 to that in 2008?
Keep it short and to the point. 0.76. What is the ratio of the Value added (in %) of Kyrgyz Republic in 2006 to that in 2008?
Give a very brief answer. 0.49. What is the ratio of the Value added (in %) of Mauritius in 2006 to that in 2008?
Your answer should be very brief. 1.07. What is the ratio of the Value added (in %) in Estonia in 2007 to that in 2008?
Your answer should be compact. 0.57. What is the ratio of the Value added (in %) of Jordan in 2007 to that in 2008?
Keep it short and to the point. 0.71. What is the ratio of the Value added (in %) in Kyrgyz Republic in 2007 to that in 2008?
Your response must be concise. 1.6. What is the ratio of the Value added (in %) in Mauritius in 2007 to that in 2008?
Offer a terse response. 1.21. What is the difference between the highest and the second highest Value added (in %) in Estonia?
Your answer should be very brief. 7.67. What is the difference between the highest and the second highest Value added (in %) of Jordan?
Your answer should be compact. 0.86. What is the difference between the highest and the second highest Value added (in %) of Kyrgyz Republic?
Your answer should be very brief. 1.19. What is the difference between the highest and the second highest Value added (in %) in Mauritius?
Your response must be concise. 0.29. What is the difference between the highest and the lowest Value added (in %) in Estonia?
Provide a succinct answer. 8.95. What is the difference between the highest and the lowest Value added (in %) in Jordan?
Offer a very short reply. 1.18. What is the difference between the highest and the lowest Value added (in %) in Kyrgyz Republic?
Give a very brief answer. 3.56. What is the difference between the highest and the lowest Value added (in %) of Mauritius?
Offer a terse response. 0.78. 